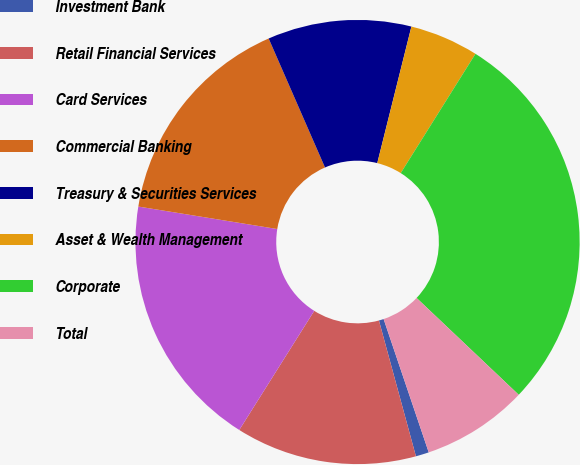Convert chart to OTSL. <chart><loc_0><loc_0><loc_500><loc_500><pie_chart><fcel>Investment Bank<fcel>Retail Financial Services<fcel>Card Services<fcel>Commercial Banking<fcel>Treasury & Securities Services<fcel>Asset & Wealth Management<fcel>Corporate<fcel>Total<nl><fcel>0.96%<fcel>13.17%<fcel>18.61%<fcel>15.89%<fcel>10.45%<fcel>5.01%<fcel>28.16%<fcel>7.73%<nl></chart> 